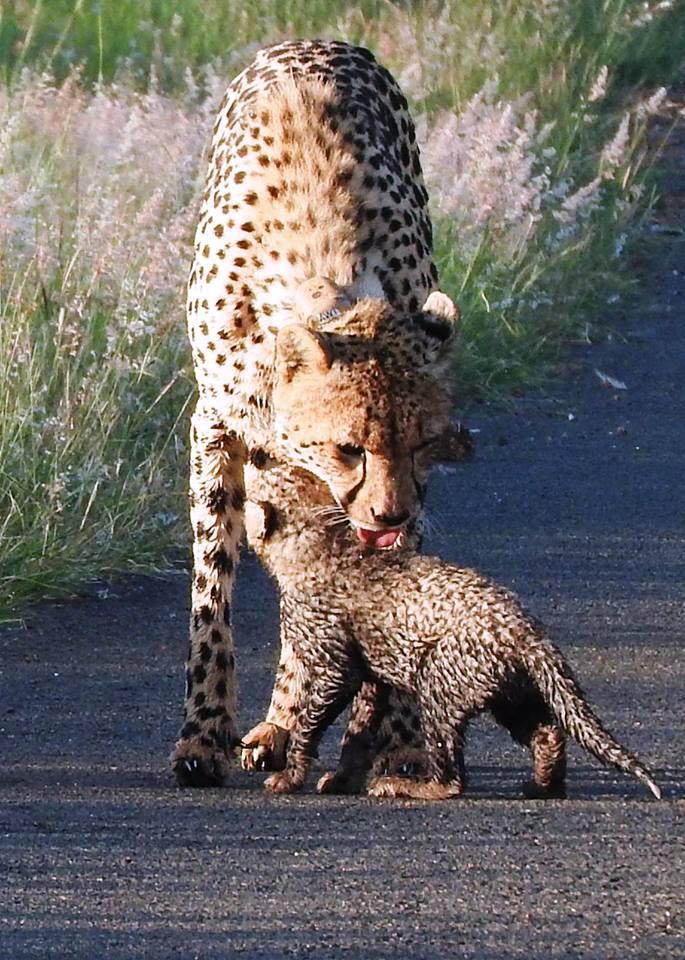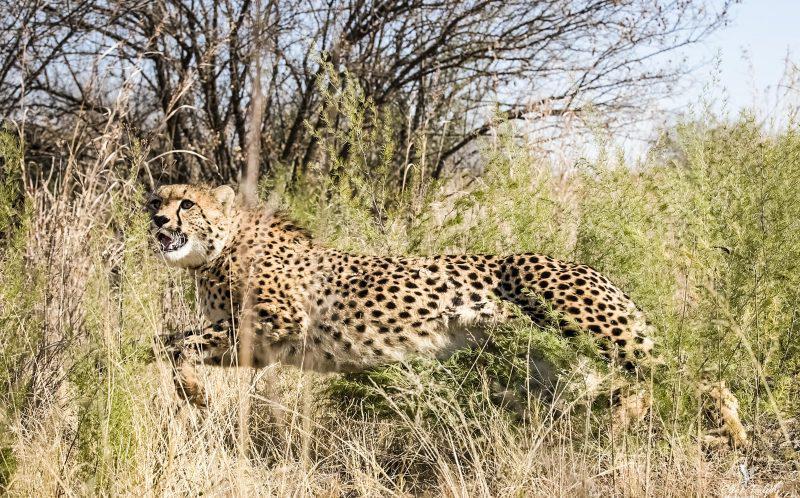The first image is the image on the left, the second image is the image on the right. Examine the images to the left and right. Is the description "The right image contains a single cheetah." accurate? Answer yes or no. Yes. The first image is the image on the left, the second image is the image on the right. Evaluate the accuracy of this statement regarding the images: "The left and right image contains the same number of cheetahs.". Is it true? Answer yes or no. No. 